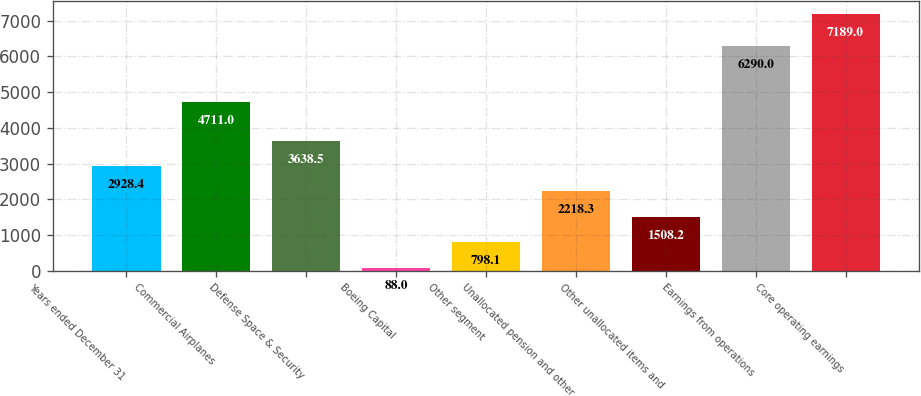Convert chart. <chart><loc_0><loc_0><loc_500><loc_500><bar_chart><fcel>Years ended December 31<fcel>Commercial Airplanes<fcel>Defense Space & Security<fcel>Boeing Capital<fcel>Other segment<fcel>Unallocated pension and other<fcel>Other unallocated items and<fcel>Earnings from operations<fcel>Core operating earnings<nl><fcel>2928.4<fcel>4711<fcel>3638.5<fcel>88<fcel>798.1<fcel>2218.3<fcel>1508.2<fcel>6290<fcel>7189<nl></chart> 